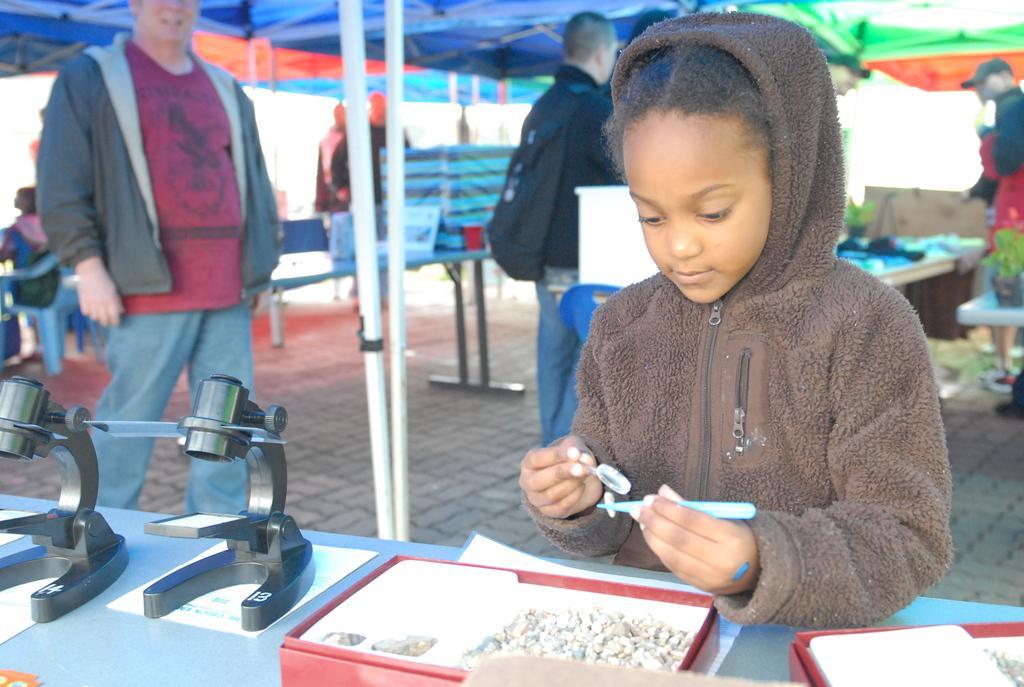Please provide a concise description of this image. This picture describes about group of people, they are all under the tent, on the left side of the image we can see microscopes, few boxes and other things on the table, in the background we can find few plants, tables and chairs. 